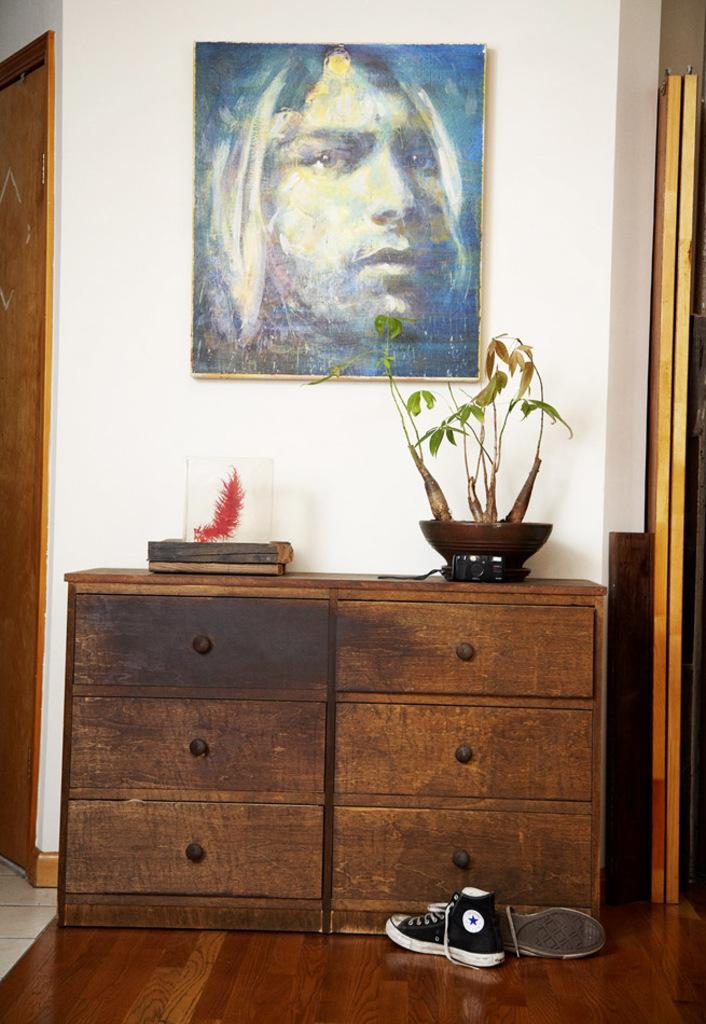What is hanging on the wall in the image? There is a photo frame on the wall. What type of plant can be seen in the image? There is a plant in a pot in the image. Where is the plant located? The plant is placed on a cupboard. What can be seen on the floor in the image? There are shoes on the floor. What type of trousers is the plant wearing in the image? There are no trousers present in the image, as plants do not wear clothing. Can you see a sail in the image? There is no sail present in the image. 